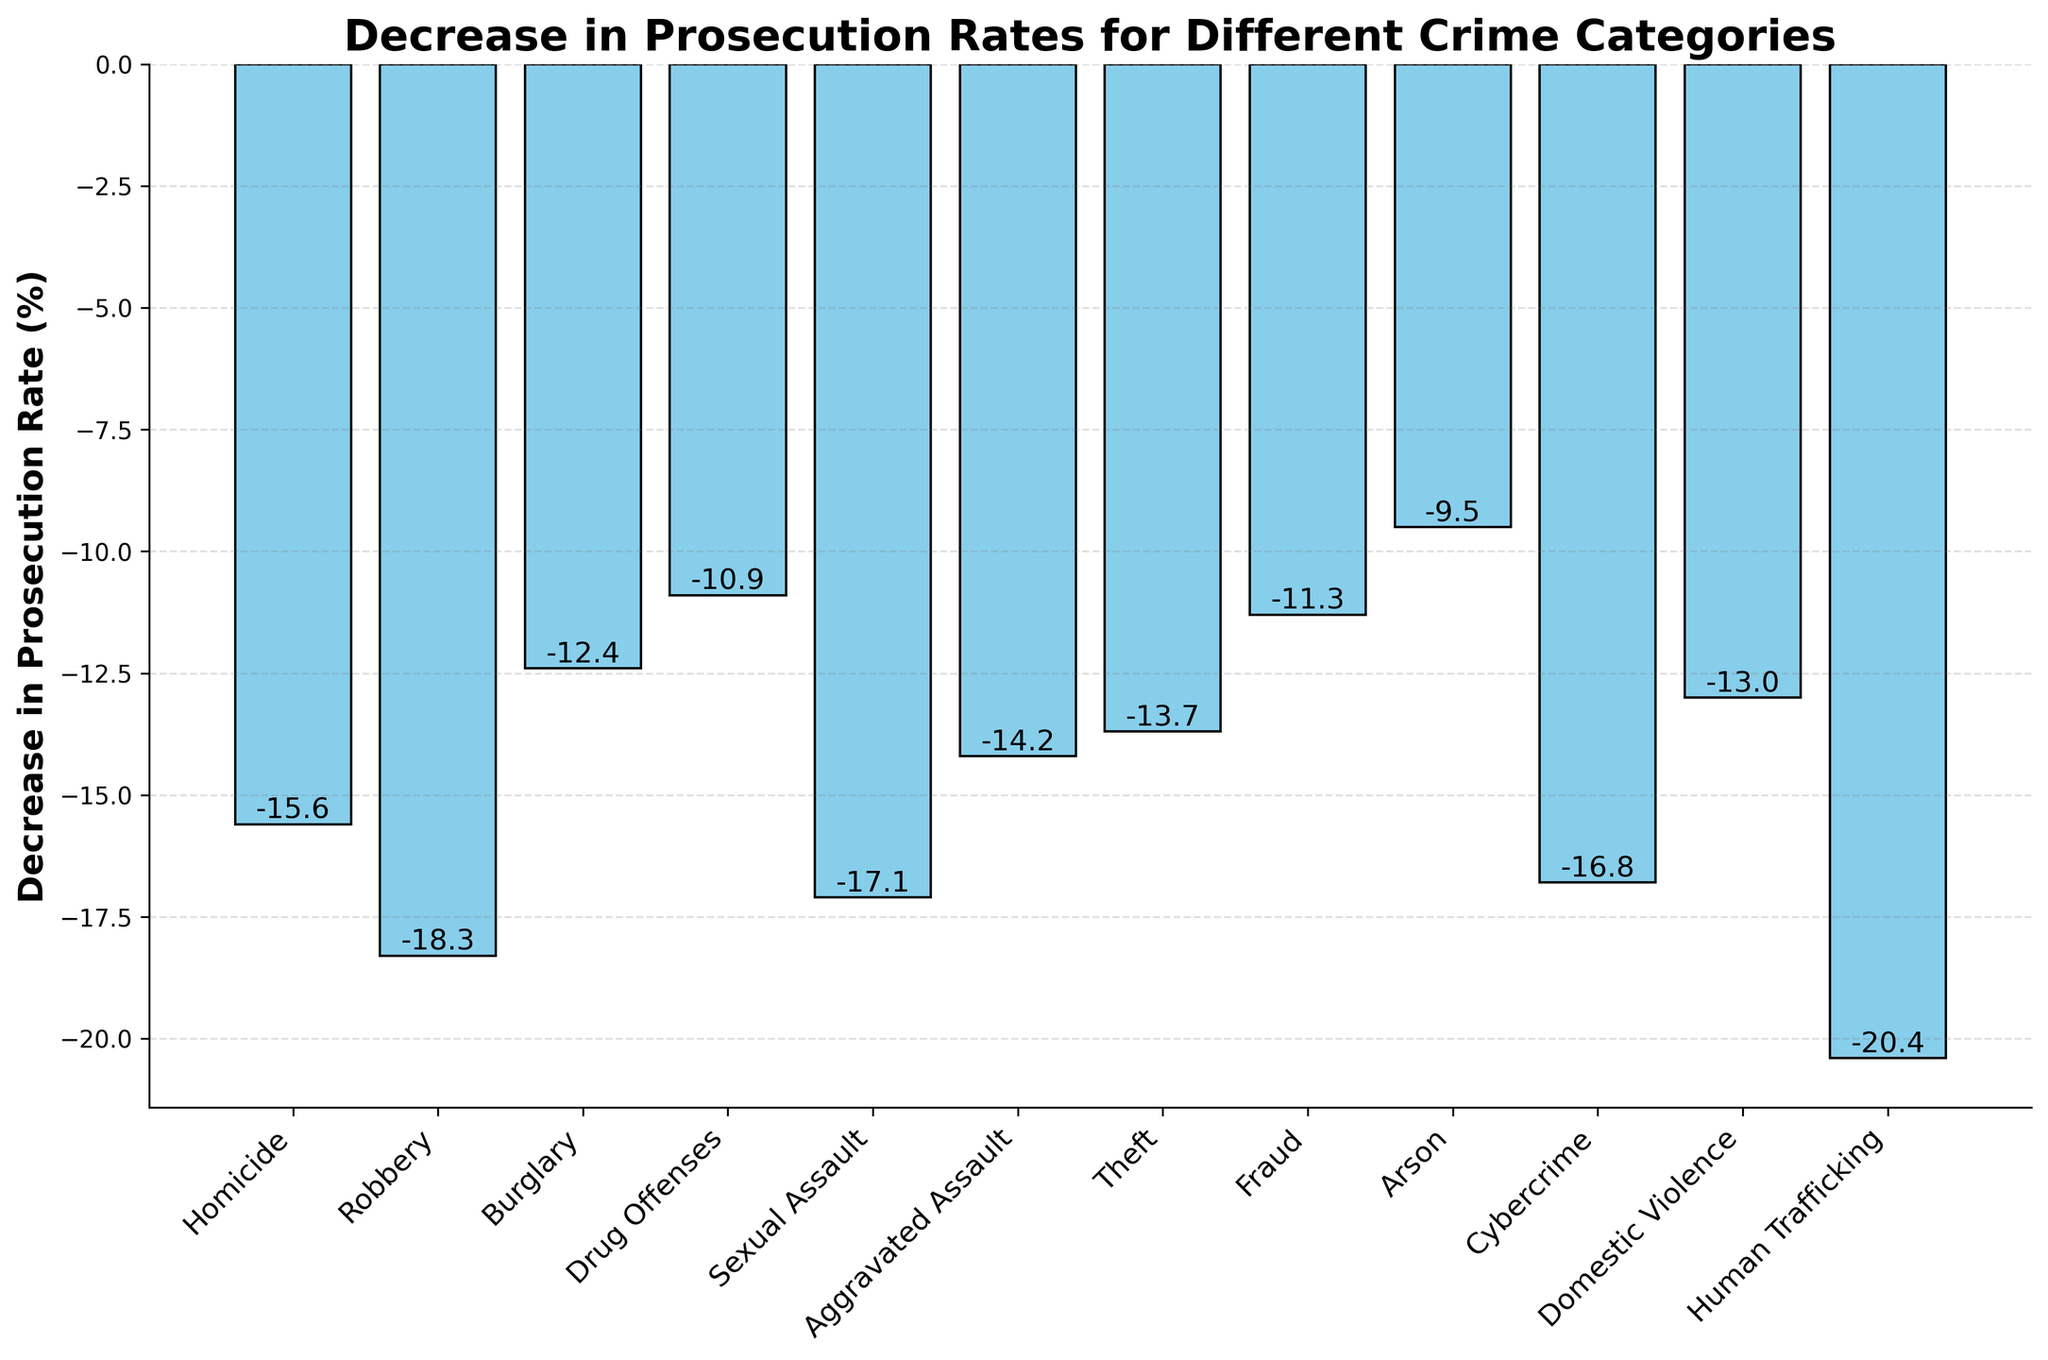Which crime category has the largest decrease in prosecution rates? To find the category with the largest decrease, find the lowest value in the dataset, which is Human Trafficking at -20.4%.
Answer: Human Trafficking Which crime category has the smallest decrease in prosecution rates? To find the crime category with the smallest decrease, look for the highest value among the negative percentages, which is Arson at -9.5%.
Answer: Arson What is the average decrease in prosecution rates across all crime categories? Sum up all the decrease percentages and divide by the number of crime categories: (-15.6 -18.3 -12.4 -10.9 -17.1 -14.2 -13.7 -11.3 -9.5 -16.8 -13.0 -20.4) / 12 = -173.2 / 12 = -14.43%
Answer: -14.43% How does the decrease in prosecution rates for Robbery compare to that of Cybercrime? The decrease for Robbery is -18.3%, and for Cybercrime, it is -16.8%. Robbery has a larger decrease than Cybercrime.
Answer: Robbery has a larger decrease Which three crime categories have the highest decrease in prosecution rates? Identify the three lowest values among the negative percentages: Human Trafficking (-20.4%), Robbery (-18.3%), and Sexual Assault (-17.1%).
Answer: Human Trafficking, Robbery, Sexual Assault What is the difference in the decrease in prosecution rates between Burglary and Drug Offenses? Subtract the decrease for Drug Offenses (-10.9%) from Burglary (-12.4%): -12.4 - (-10.9) = -12.4 + 10.9 = -1.5%
Answer: -1.5% What is the combined decrease in prosecution rates for Theft and Fraud? Add the decrease percentages for Theft (-13.7%) and Fraud (-11.3%): -13.7 + -11.3 = -25.0%
Answer: -25.0% How many crime categories have a decrease in prosecution rates above 15%? Count the number of categories with decrease percentages greater than 15% in magnitude: Human Trafficking (-20.4%), Robbery (-18.3%), Cybercrime (-16.8%), Sexual Assault (-17.1%), and Homicide (-15.6%).
Answer: 5 Is the decrease in prosecution rates for Domestic Violence higher or lower than the overall average? The average decrease is -14.43%. The decrease for Domestic Violence is -13.0%, which is smaller in magnitude than the average.
Answer: Lower 